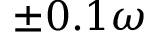Convert formula to latex. <formula><loc_0><loc_0><loc_500><loc_500>\pm 0 . 1 \omega</formula> 